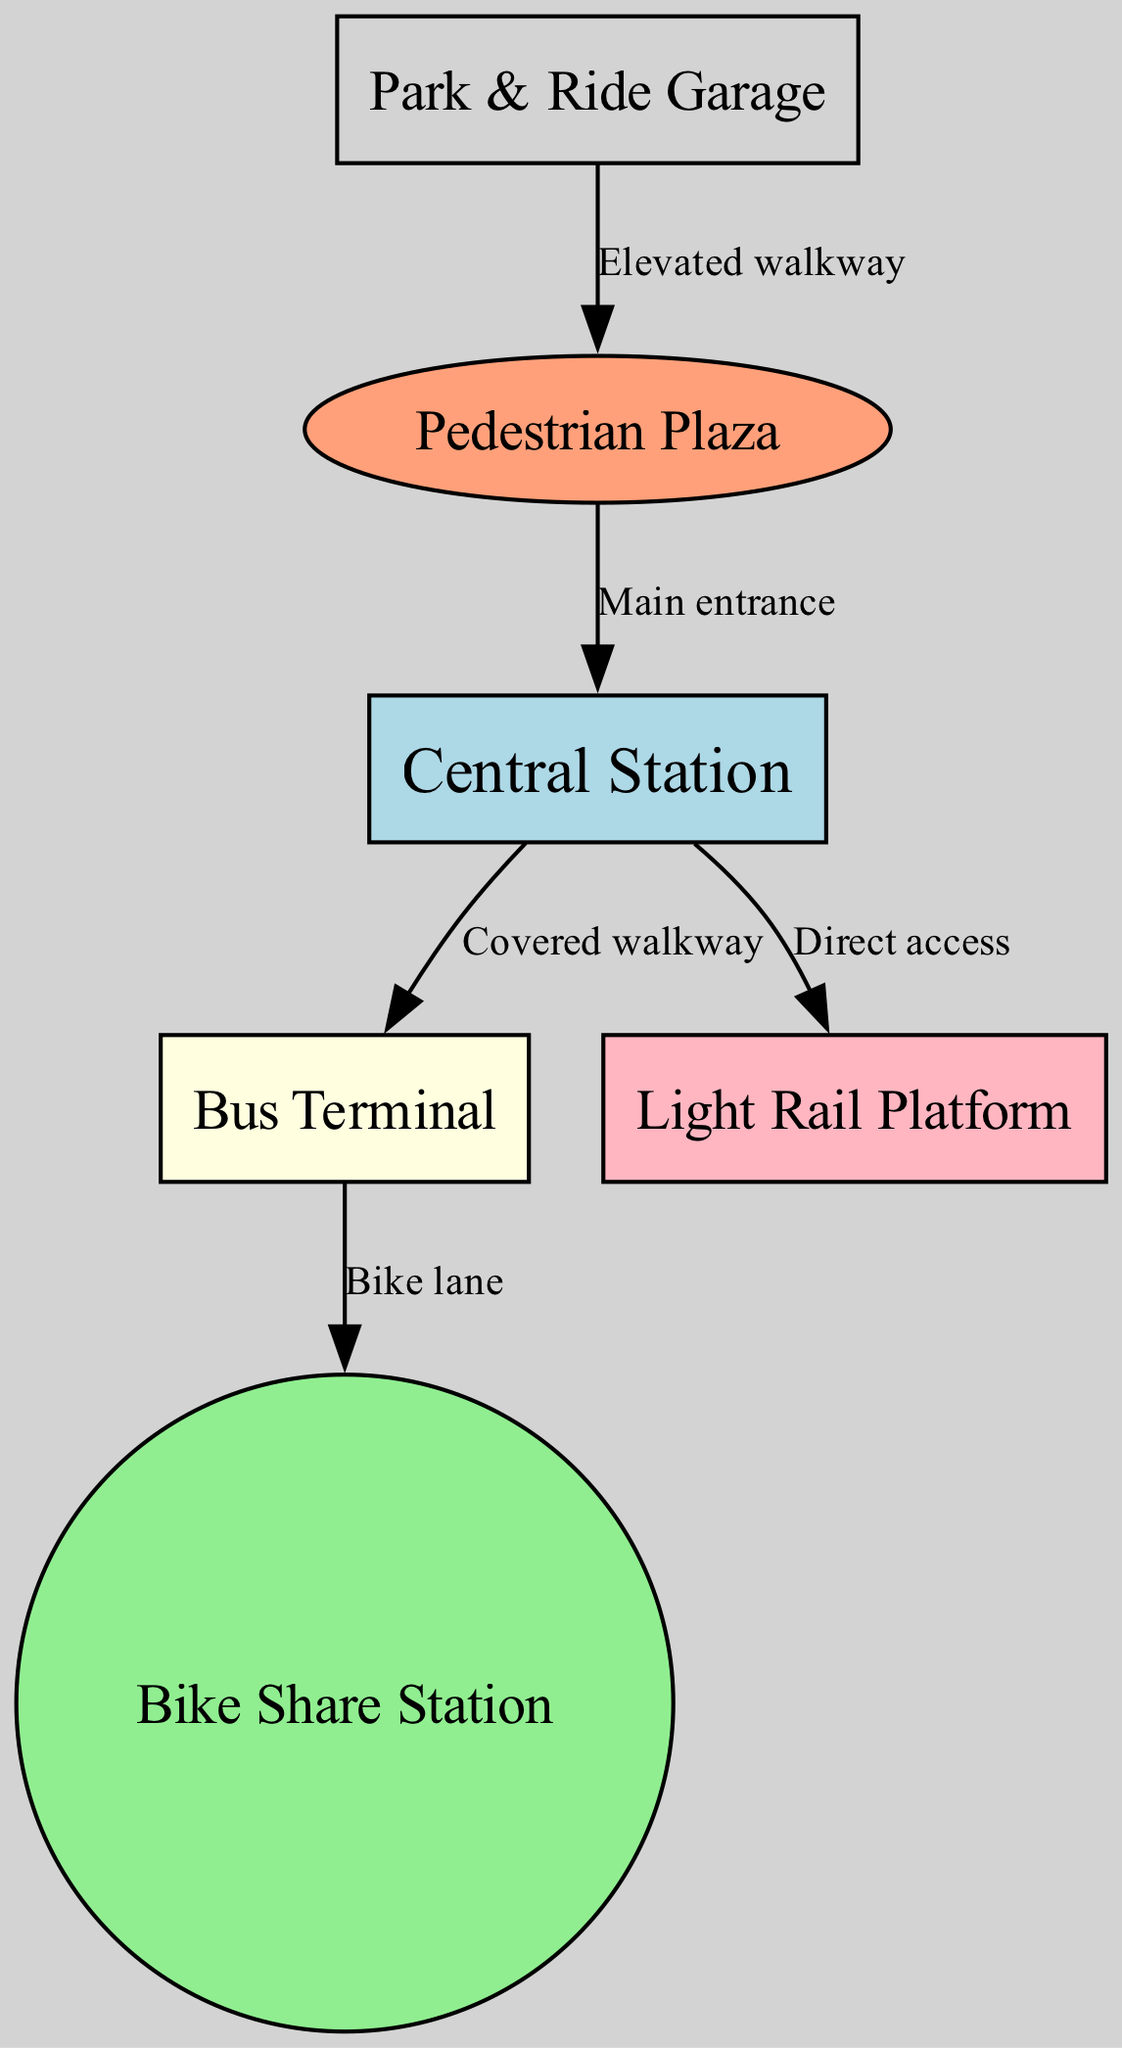What is the main entrance of the intermodal transportation hub? The diagram shows a direct connection labeled "Main entrance" from the pedestrian plaza to the central station, indicating that the central station is the main entrance of the hub.
Answer: Central Station How many nodes are in the diagram? By counting the distinct nodes listed in the data (central_station, bus_terminal, bike_share, parking_garage, light_rail, pedestrian_plaza), we find there are a total of 6 nodes.
Answer: 6 What type of access connects Central Station to Light Rail? The edge connecting Central Station to Light Rail is labeled "Direct access," indicating the type of connection between these two nodes.
Answer: Direct access Which node is directly connected to the Bus Terminal? The data shows an edge from the bus_terminal to the bike_share with the label "Bike lane," indicating that the bike share station is directly connected to the bus terminal.
Answer: Bike Share Station How many edges are there in total in the diagram? By examining the data, we can count the edges listed (5 edges), confirming that there are 5 connections between the nodes.
Answer: 5 What is the purpose of the elevated walkway in the diagram? The edge from the parking garage to the pedestrian plaza is labeled "Elevated walkway," indicating that its purpose is to connect the parking garage to the pedestrian plaza for safe pedestrian access.
Answer: Connect parking garage to pedestrian plaza What color represents the Bike Share Station in the diagram? The node for the Bike Share Station is described with a fill color of "lightgreen" in the styling information, making it easy to identify visually.
Answer: Light green Which node has a direct link to the Central Station? From the data, there are two nodes that have direct links to the Central Station: the bus terminal and the light rail platform, as indicated by the edges leading to each of them.
Answer: Bus Terminal, Light Rail Platform What is the primary function of the Pedestrian Plaza? The pedestrian plaza serves as a main access point connecting to various transportation modes, with edges leading to the central station and the parking garage, thus it acts as a central hub for pedestrian movement.
Answer: Central access point 